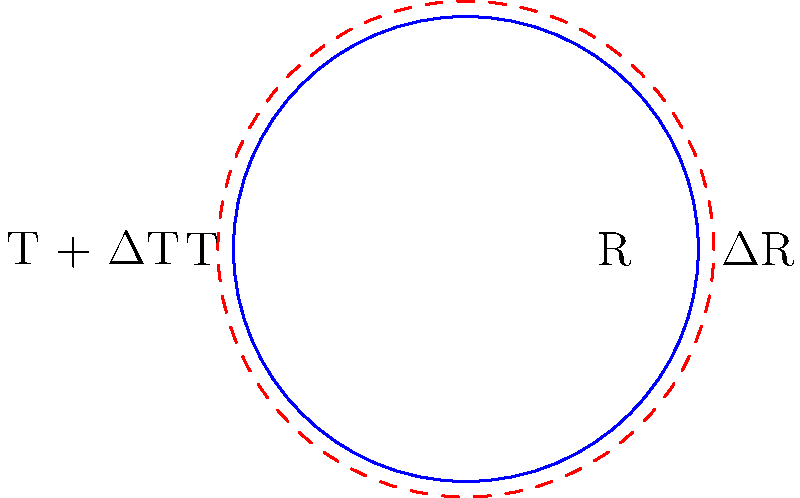A circular disk made of a metallic alloy has an initial radius R = 50 cm at temperature T = 20°C. If the temperature is increased by ΔT = 80°C and the coefficient of linear thermal expansion for the alloy is α = 1.8 × 10⁻⁵ /°C, calculate the increase in the disk's area. Express your answer in square centimeters (cm²). To solve this problem, we'll follow these steps:

1) First, recall the formula for linear thermal expansion:
   $$\Delta L = \alpha L_0 \Delta T$$
   where ΔL is the change in length, α is the coefficient of linear thermal expansion, L₀ is the initial length, and ΔT is the change in temperature.

2) In our case, L₀ is the radius R. So, the change in radius ΔR is:
   $$\Delta R = \alpha R \Delta T$$
   $$\Delta R = (1.8 \times 10^{-5})(50)(80) = 0.072 \text{ cm}$$

3) The new radius R' is thus:
   $$R' = R + \Delta R = 50 + 0.072 = 50.072 \text{ cm}$$

4) Now, we need to calculate the change in area. The initial area A₁ is:
   $$A_1 = \pi R^2 = \pi (50)^2 = 7853.98 \text{ cm}^2$$

5) The new area A₂ is:
   $$A_2 = \pi (R')^2 = \pi (50.072)^2 = 7875.69 \text{ cm}^2$$

6) The increase in area ΔA is:
   $$\Delta A = A_2 - A_1 = 7875.69 - 7853.98 = 21.71 \text{ cm}^2$$

Therefore, the increase in the disk's area is approximately 21.71 cm².
Answer: 21.71 cm² 